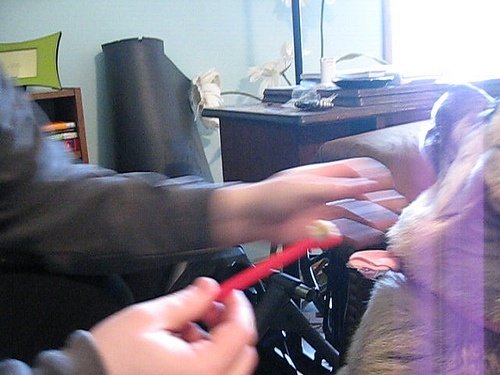Describe the objects in this image and their specific colors. I can see people in darkgray, black, gray, lightpink, and pink tones, dog in darkgray, violet, gray, and lavender tones, couch in darkgray, gray, and lavender tones, toothbrush in darkgray, brown, salmon, black, and lightpink tones, and book in darkgray, gray, and black tones in this image. 